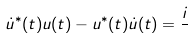<formula> <loc_0><loc_0><loc_500><loc_500>\dot { u } ^ { * } ( t ) u ( t ) - u ^ { * } ( t ) \dot { u } ( t ) = \frac { i } { }</formula> 